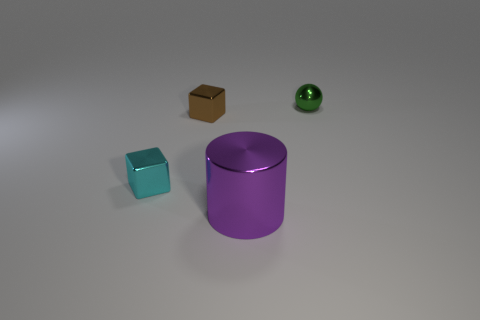Is the lighting in the scene natural or artificial? The lighting in the image simulates an artificial source, giving off a soft glow that diffusely illuminates the objects and casts gentle shadows, indicative of a controlled indoor setting. 